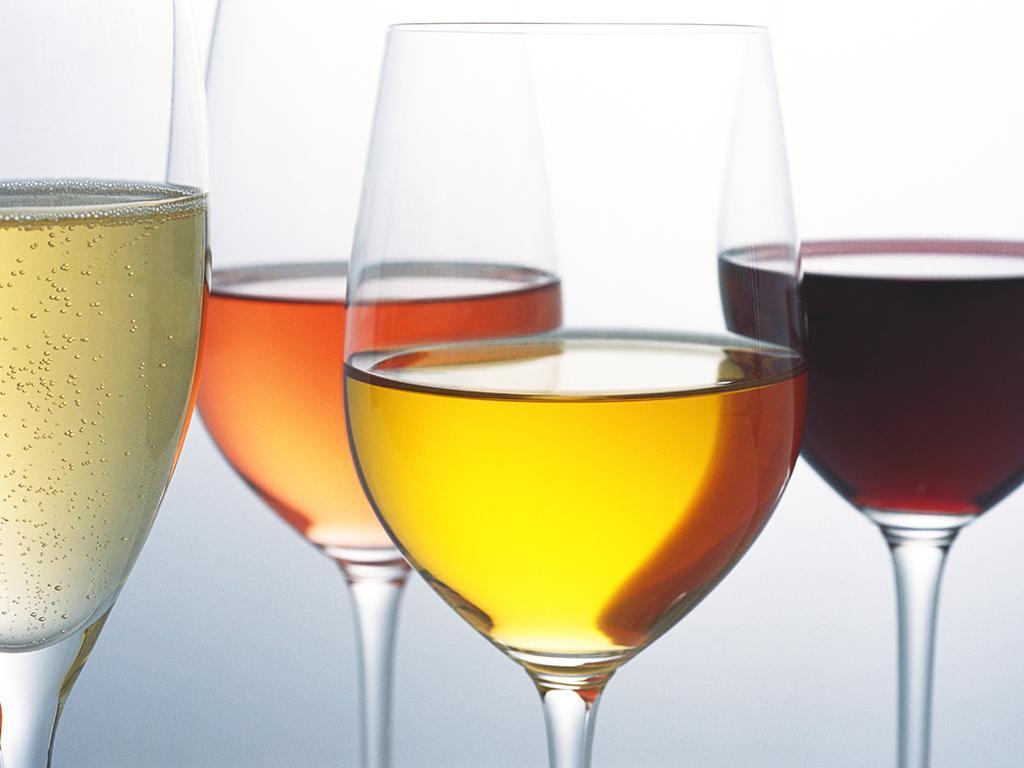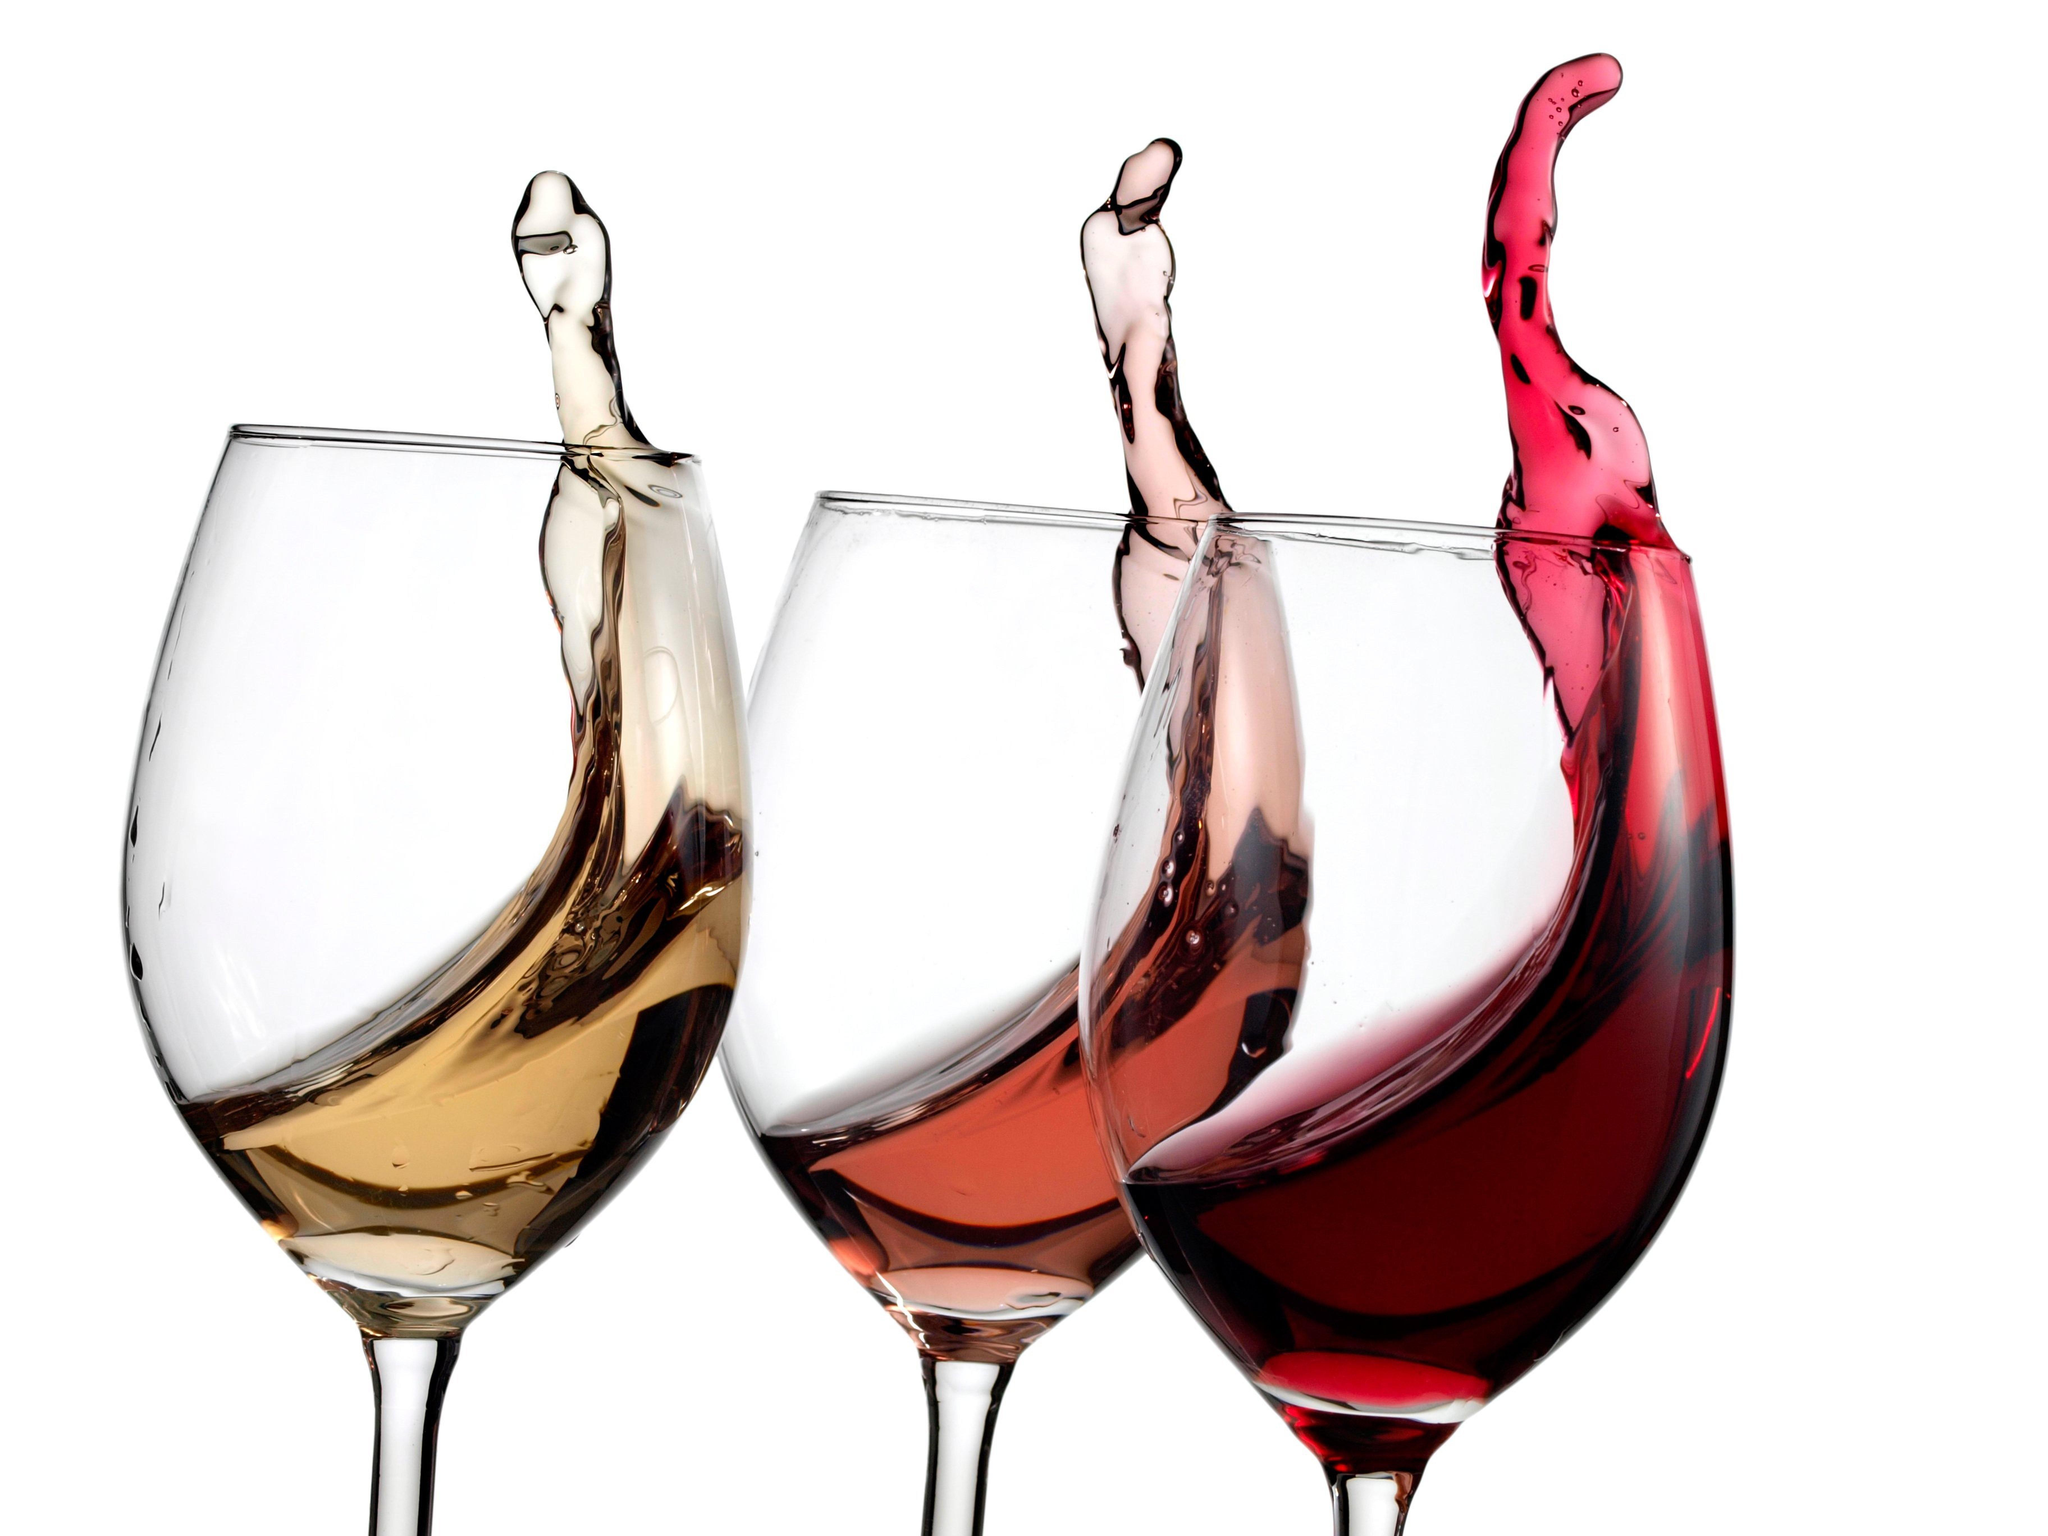The first image is the image on the left, the second image is the image on the right. For the images displayed, is the sentence "Each image shows exactly three wine glasses, which contain different colors of wine." factually correct? Answer yes or no. No. The first image is the image on the left, the second image is the image on the right. For the images displayed, is the sentence "The wine glass furthest to the right in the right image contains dark red liquid." factually correct? Answer yes or no. Yes. 